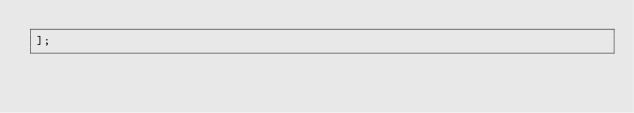Convert code to text. <code><loc_0><loc_0><loc_500><loc_500><_JavaScript_>];
</code> 